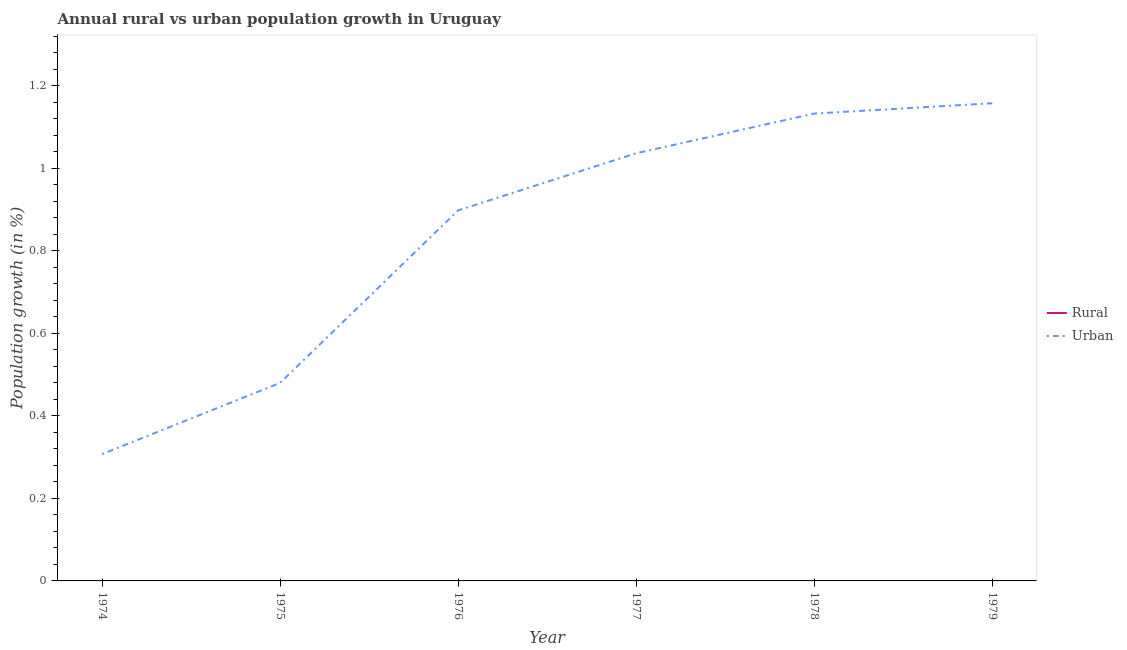Does the line corresponding to urban population growth intersect with the line corresponding to rural population growth?
Provide a succinct answer. No. What is the rural population growth in 1979?
Ensure brevity in your answer.  0. Across all years, what is the maximum urban population growth?
Make the answer very short. 1.16. In which year was the urban population growth maximum?
Provide a short and direct response. 1979. What is the total urban population growth in the graph?
Your answer should be very brief. 5.01. What is the difference between the urban population growth in 1978 and that in 1979?
Keep it short and to the point. -0.03. What is the difference between the rural population growth in 1974 and the urban population growth in 1976?
Provide a succinct answer. -0.9. In how many years, is the rural population growth greater than 1.04 %?
Keep it short and to the point. 0. What is the ratio of the urban population growth in 1978 to that in 1979?
Make the answer very short. 0.98. Is the urban population growth in 1978 less than that in 1979?
Make the answer very short. Yes. What is the difference between the highest and the second highest urban population growth?
Provide a succinct answer. 0.03. What is the difference between the highest and the lowest urban population growth?
Your answer should be compact. 0.85. Does the rural population growth monotonically increase over the years?
Provide a succinct answer. No. How many lines are there?
Your answer should be compact. 1. What is the difference between two consecutive major ticks on the Y-axis?
Your response must be concise. 0.2. Does the graph contain grids?
Your answer should be compact. No. What is the title of the graph?
Provide a short and direct response. Annual rural vs urban population growth in Uruguay. Does "By country of asylum" appear as one of the legend labels in the graph?
Your response must be concise. No. What is the label or title of the X-axis?
Your answer should be very brief. Year. What is the label or title of the Y-axis?
Keep it short and to the point. Population growth (in %). What is the Population growth (in %) in Urban  in 1974?
Ensure brevity in your answer.  0.31. What is the Population growth (in %) in Urban  in 1975?
Offer a terse response. 0.48. What is the Population growth (in %) of Rural in 1976?
Provide a succinct answer. 0. What is the Population growth (in %) of Urban  in 1976?
Give a very brief answer. 0.9. What is the Population growth (in %) of Rural in 1977?
Offer a terse response. 0. What is the Population growth (in %) in Urban  in 1977?
Ensure brevity in your answer.  1.04. What is the Population growth (in %) of Urban  in 1978?
Your answer should be very brief. 1.13. What is the Population growth (in %) of Urban  in 1979?
Keep it short and to the point. 1.16. Across all years, what is the maximum Population growth (in %) in Urban ?
Ensure brevity in your answer.  1.16. Across all years, what is the minimum Population growth (in %) of Urban ?
Offer a terse response. 0.31. What is the total Population growth (in %) in Rural in the graph?
Keep it short and to the point. 0. What is the total Population growth (in %) of Urban  in the graph?
Ensure brevity in your answer.  5.01. What is the difference between the Population growth (in %) in Urban  in 1974 and that in 1975?
Your answer should be compact. -0.17. What is the difference between the Population growth (in %) of Urban  in 1974 and that in 1976?
Your answer should be compact. -0.59. What is the difference between the Population growth (in %) in Urban  in 1974 and that in 1977?
Make the answer very short. -0.73. What is the difference between the Population growth (in %) in Urban  in 1974 and that in 1978?
Your answer should be very brief. -0.83. What is the difference between the Population growth (in %) of Urban  in 1974 and that in 1979?
Make the answer very short. -0.85. What is the difference between the Population growth (in %) of Urban  in 1975 and that in 1976?
Make the answer very short. -0.42. What is the difference between the Population growth (in %) of Urban  in 1975 and that in 1977?
Give a very brief answer. -0.56. What is the difference between the Population growth (in %) in Urban  in 1975 and that in 1978?
Provide a short and direct response. -0.65. What is the difference between the Population growth (in %) of Urban  in 1975 and that in 1979?
Your response must be concise. -0.68. What is the difference between the Population growth (in %) in Urban  in 1976 and that in 1977?
Provide a short and direct response. -0.14. What is the difference between the Population growth (in %) of Urban  in 1976 and that in 1978?
Keep it short and to the point. -0.23. What is the difference between the Population growth (in %) of Urban  in 1976 and that in 1979?
Your answer should be compact. -0.26. What is the difference between the Population growth (in %) in Urban  in 1977 and that in 1978?
Give a very brief answer. -0.1. What is the difference between the Population growth (in %) in Urban  in 1977 and that in 1979?
Your answer should be compact. -0.12. What is the difference between the Population growth (in %) in Urban  in 1978 and that in 1979?
Provide a succinct answer. -0.03. What is the average Population growth (in %) of Urban  per year?
Your answer should be compact. 0.84. What is the ratio of the Population growth (in %) in Urban  in 1974 to that in 1975?
Offer a very short reply. 0.64. What is the ratio of the Population growth (in %) of Urban  in 1974 to that in 1976?
Provide a short and direct response. 0.34. What is the ratio of the Population growth (in %) in Urban  in 1974 to that in 1977?
Keep it short and to the point. 0.3. What is the ratio of the Population growth (in %) of Urban  in 1974 to that in 1978?
Your answer should be very brief. 0.27. What is the ratio of the Population growth (in %) of Urban  in 1974 to that in 1979?
Provide a succinct answer. 0.27. What is the ratio of the Population growth (in %) of Urban  in 1975 to that in 1976?
Your answer should be very brief. 0.53. What is the ratio of the Population growth (in %) in Urban  in 1975 to that in 1977?
Provide a short and direct response. 0.46. What is the ratio of the Population growth (in %) in Urban  in 1975 to that in 1978?
Your answer should be compact. 0.42. What is the ratio of the Population growth (in %) of Urban  in 1975 to that in 1979?
Keep it short and to the point. 0.41. What is the ratio of the Population growth (in %) in Urban  in 1976 to that in 1977?
Make the answer very short. 0.87. What is the ratio of the Population growth (in %) of Urban  in 1976 to that in 1978?
Provide a short and direct response. 0.79. What is the ratio of the Population growth (in %) in Urban  in 1976 to that in 1979?
Keep it short and to the point. 0.78. What is the ratio of the Population growth (in %) in Urban  in 1977 to that in 1978?
Give a very brief answer. 0.92. What is the ratio of the Population growth (in %) in Urban  in 1977 to that in 1979?
Provide a succinct answer. 0.9. What is the ratio of the Population growth (in %) in Urban  in 1978 to that in 1979?
Your response must be concise. 0.98. What is the difference between the highest and the second highest Population growth (in %) of Urban ?
Your answer should be very brief. 0.03. What is the difference between the highest and the lowest Population growth (in %) in Urban ?
Your response must be concise. 0.85. 